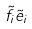<formula> <loc_0><loc_0><loc_500><loc_500>\tilde { f } _ { i } \tilde { e } _ { i }</formula> 